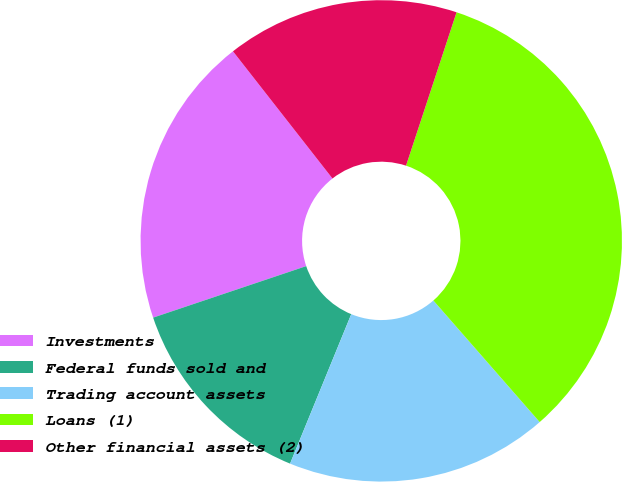Convert chart to OTSL. <chart><loc_0><loc_0><loc_500><loc_500><pie_chart><fcel>Investments<fcel>Federal funds sold and<fcel>Trading account assets<fcel>Loans (1)<fcel>Other financial assets (2)<nl><fcel>19.6%<fcel>13.65%<fcel>17.62%<fcel>33.5%<fcel>15.63%<nl></chart> 